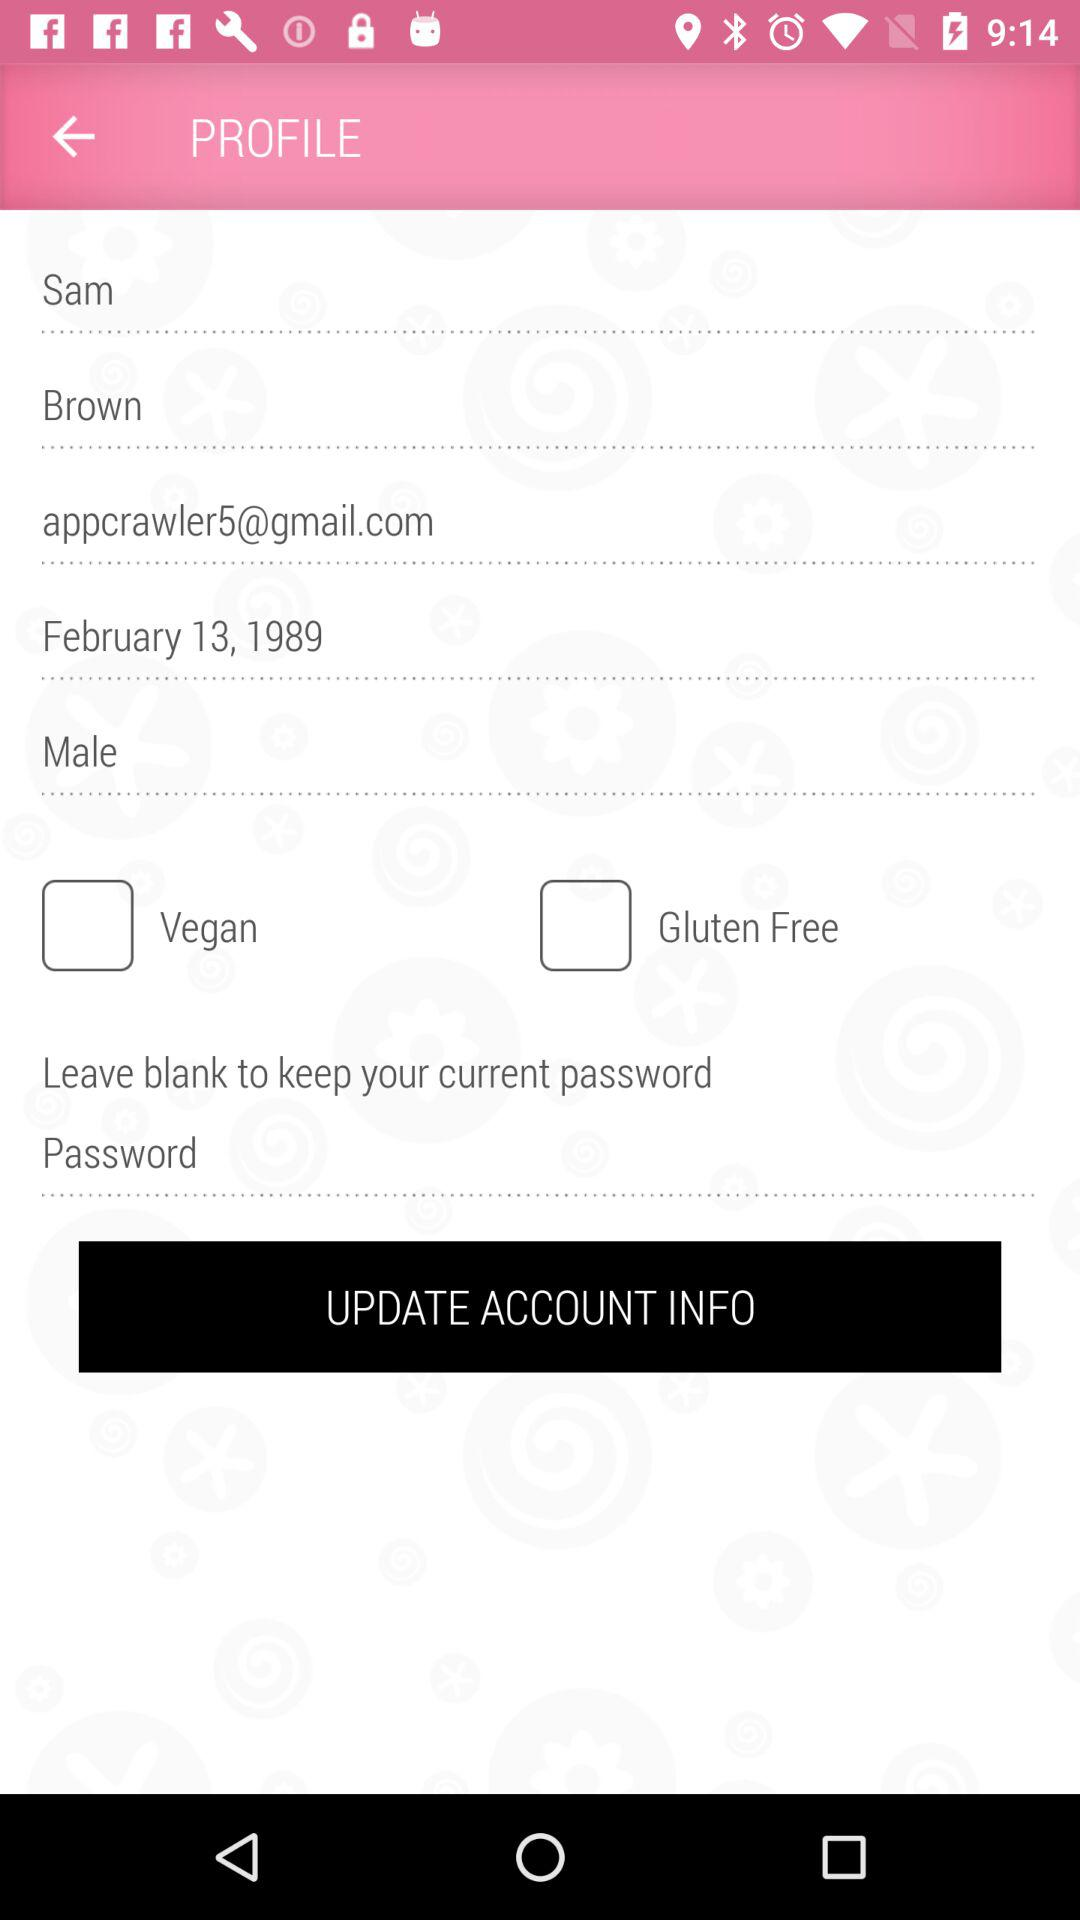Which gender has been mentioned? The mentioned gender is male. 